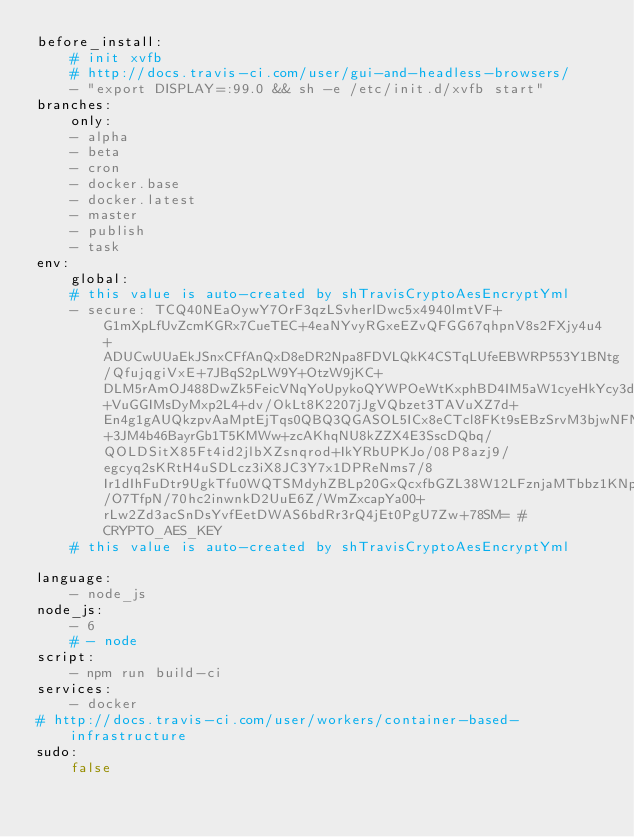<code> <loc_0><loc_0><loc_500><loc_500><_YAML_>before_install:
    # init xvfb
    # http://docs.travis-ci.com/user/gui-and-headless-browsers/
    - "export DISPLAY=:99.0 && sh -e /etc/init.d/xvfb start"
branches:
    only:
    - alpha
    - beta
    - cron
    - docker.base
    - docker.latest
    - master
    - publish
    - task
env:
    global:
    # this value is auto-created by shTravisCryptoAesEncryptYml
    - secure: TCQ40NEaOywY7OrF3qzLSvherlDwc5x4940lmtVF+G1mXpLfUvZcmKGRx7CueTEC+4eaNYvyRGxeEZvQFGG67qhpnV8s2FXjy4u4+ADUCwUUaEkJSnxCFfAnQxD8eDR2Npa8FDVLQkK4CSTqLUfeEBWRP553Y1BNtg/QfujqgiVxE+7JBqS2pLW9Y+OtzW9jKC+DLM5rAmOJ488DwZk5FeicVNqYoUpykoQYWPOeWtKxphBD4IM5aW1cyeHkYcy3d0vZamvi+VuGGIMsDyMxp2L4+dv/OkLt8K2207jJgVQbzet3TAVuXZ7d+En4g1gAUQkzpvAaMptEjTqs0QBQ3QGASOL5ICx8eCTcl8FKt9sEBzSrvM3bjwNFNqGSB2Lc4FwcXiBzDKM+3JM4b46BayrGb1T5KMWw+zcAKhqNU8kZZX4E3SscDQbq/QOLDSitX85Ft4id2jlbXZsnqrod+IkYRbUPKJo/08P8azj9/egcyq2sKRtH4uSDLcz3iX8JC3Y7x1DPReNms7/8Ir1dIhFuDtr9UgkTfu0WQTSMdyhZBLp20GxQcxfbGZL38W12LFznjaMTbbz1KNpIb6M8kR/O7TfpN/70hc2inwnkD2UuE6Z/WmZxcapYa00+rLw2Zd3acSnDsYvfEetDWAS6bdRr3rQ4jEt0PgU7Zw+78SM= # CRYPTO_AES_KEY
    # this value is auto-created by shTravisCryptoAesEncryptYml

language:
    - node_js
node_js:
    - 6
    # - node
script:
    - npm run build-ci
services:
    - docker
# http://docs.travis-ci.com/user/workers/container-based-infrastructure
sudo:
    false
</code> 